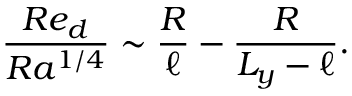<formula> <loc_0><loc_0><loc_500><loc_500>\frac { R e _ { d } } { R a ^ { 1 / 4 } } \sim \frac { R } { \ell } - \frac { R } { L _ { y } - \ell } .</formula> 